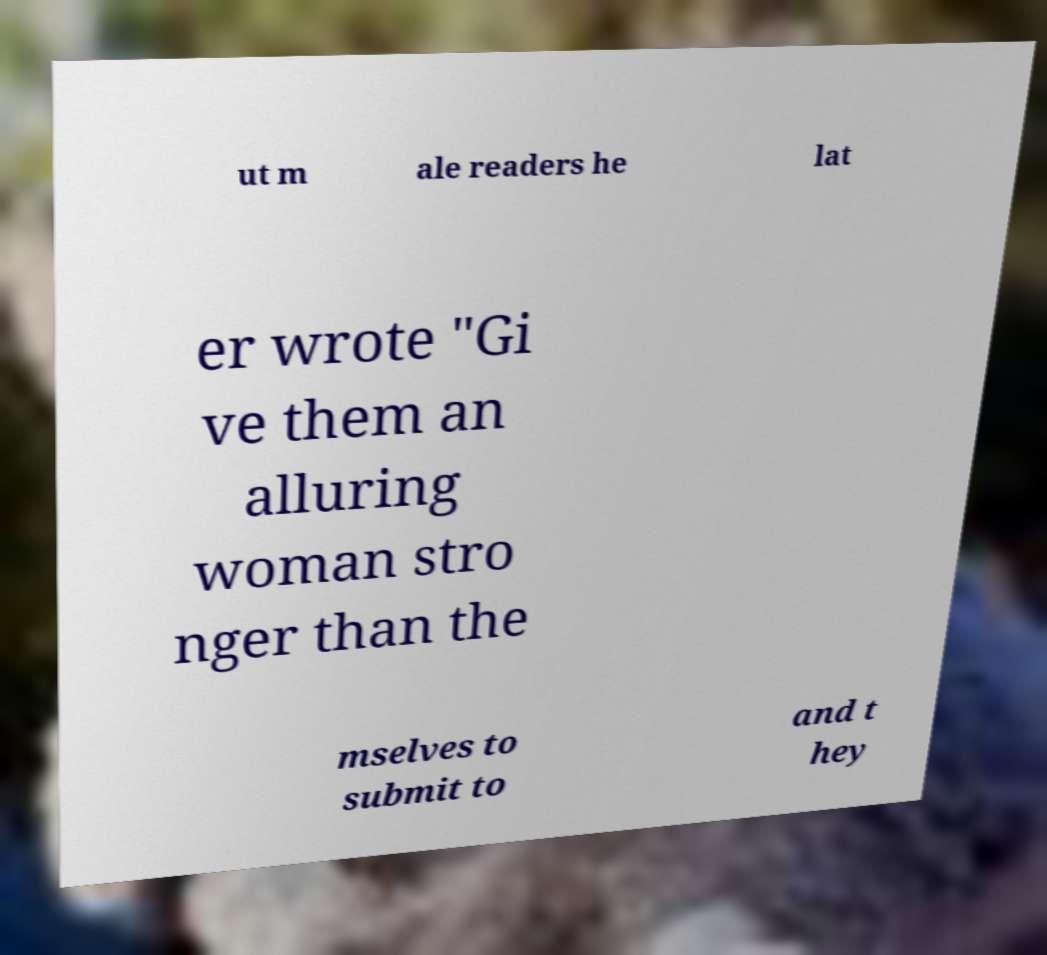Can you read and provide the text displayed in the image?This photo seems to have some interesting text. Can you extract and type it out for me? ut m ale readers he lat er wrote "Gi ve them an alluring woman stro nger than the mselves to submit to and t hey 